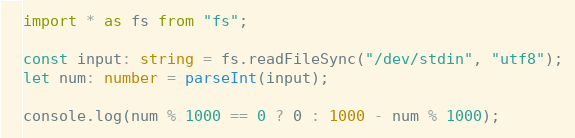<code> <loc_0><loc_0><loc_500><loc_500><_TypeScript_>import * as fs from "fs";

const input: string = fs.readFileSync("/dev/stdin", "utf8");
let num: number = parseInt(input);

console.log(num % 1000 == 0 ? 0 : 1000 - num % 1000);
</code> 